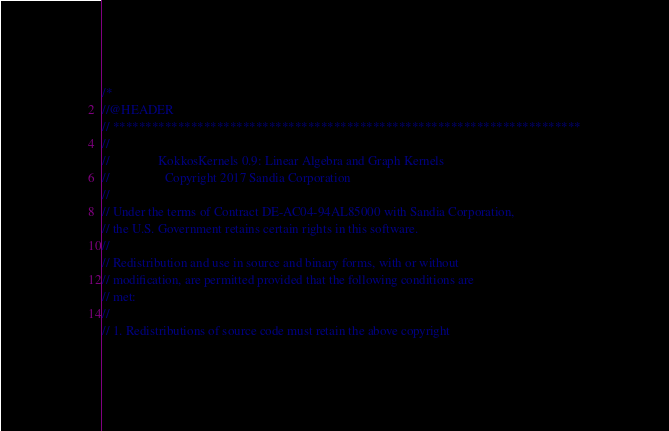Convert code to text. <code><loc_0><loc_0><loc_500><loc_500><_C++_>/*
//@HEADER
// ************************************************************************
//
//               KokkosKernels 0.9: Linear Algebra and Graph Kernels
//                 Copyright 2017 Sandia Corporation
//
// Under the terms of Contract DE-AC04-94AL85000 with Sandia Corporation,
// the U.S. Government retains certain rights in this software.
//
// Redistribution and use in source and binary forms, with or without
// modification, are permitted provided that the following conditions are
// met:
//
// 1. Redistributions of source code must retain the above copyright</code> 